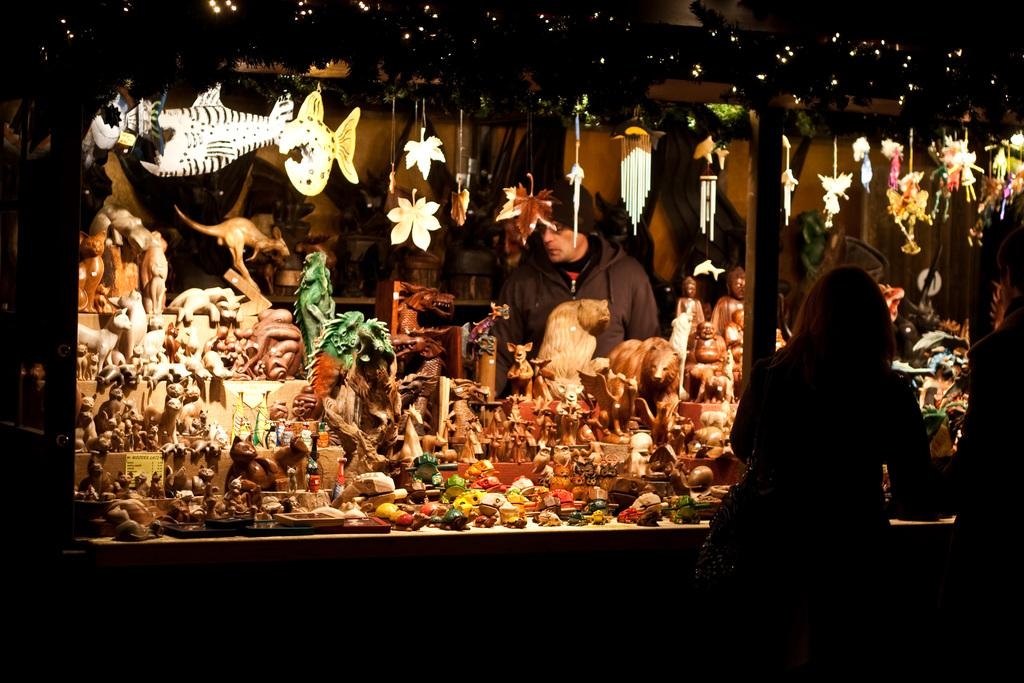What type of art is featured in the image? There are sculptures in the image. What is the platform holding in the image? Small objects are present on a platform in the image. What is hanging at the top of the image? Objects are hanging at the top of the image. Can you describe the people in the image? There are persons in the image. What type of lighting is present in the image? Decorative lights are visible in the image. What other objects can be seen in the image? There are additional objects in the image. What is the reaction of the stone to the peace in the image? There is no stone or peace present in the image; it features sculptures, small objects, hanging objects, persons, decorative lights, and additional objects. 